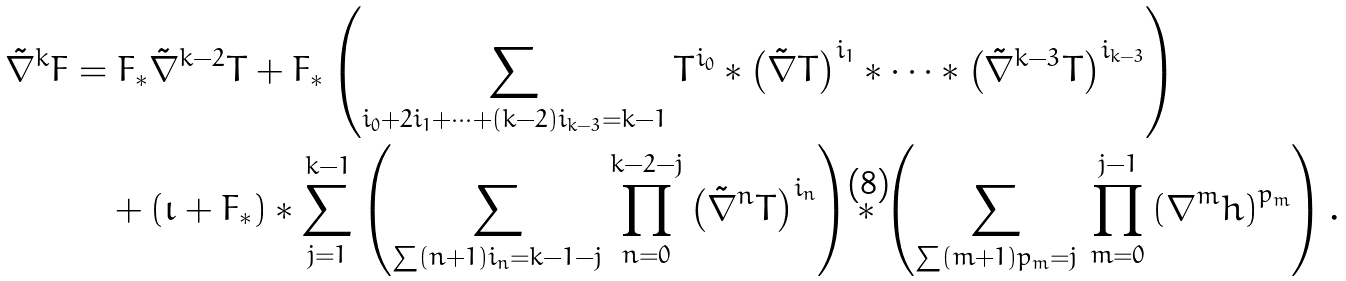<formula> <loc_0><loc_0><loc_500><loc_500>\tilde { \nabla } ^ { k } F & = F _ { * } \tilde { \nabla } ^ { k - 2 } T + F _ { * } \left ( \sum _ { i _ { 0 } + 2 i _ { 1 } + \dots + ( k - 2 ) i _ { k - 3 } = k - 1 } T ^ { i _ { 0 } } \ast \left ( \tilde { \nabla } T \right ) ^ { i _ { 1 } } \ast \dots \ast \left ( \tilde { \nabla } ^ { k - 3 } T \right ) ^ { i _ { k - 3 } } \right ) \\ & \quad \null + ( \iota + F _ { * } ) \ast \sum _ { j = 1 } ^ { k - 1 } \left ( \sum _ { \sum ( n + 1 ) i _ { n } = k - 1 - j } \prod _ { n = 0 } ^ { k - 2 - j } \left ( \tilde { \nabla } ^ { n } T \right ) ^ { i _ { n } } \right ) \ast \left ( \sum _ { \sum ( m + 1 ) p _ { m } = j } \, \prod _ { m = 0 } ^ { j - 1 } \left ( \nabla ^ { m } h \right ) ^ { p _ { m } } \right ) .</formula> 